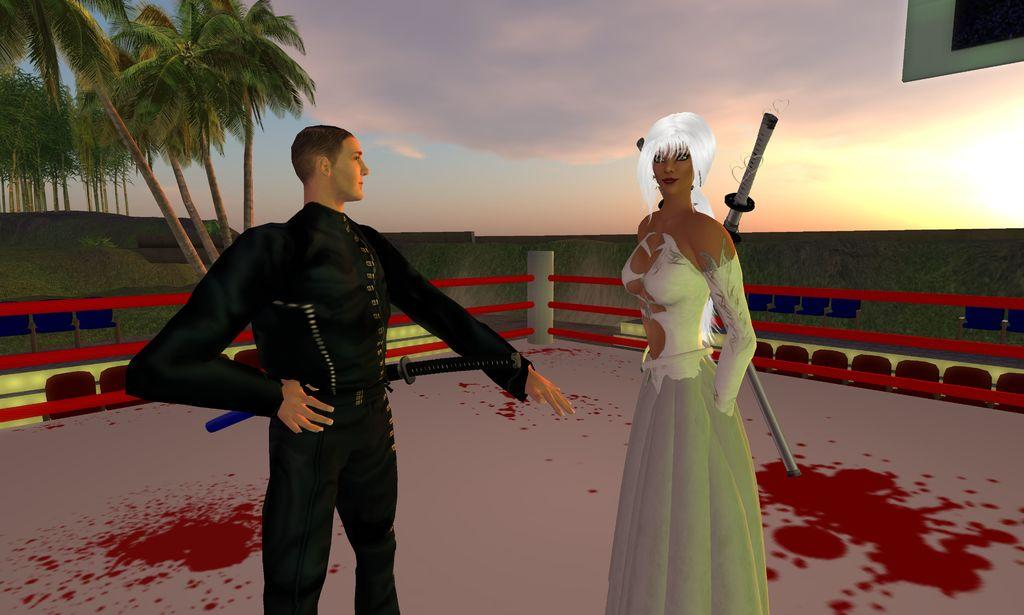What type of image is being described? The image is animated. Can you describe the characters in the image? There is a man and a woman in the image. What are the man and woman holding? Both the man and woman are holding swords. What can be seen in the background of the image? There is a railing, trees, and the sky visible in the background of the image. What type of gun can be seen in the image? There is no gun present in the image; both the man and woman are holding swords. How many pears are visible in the image? There are no pears present in the image. 